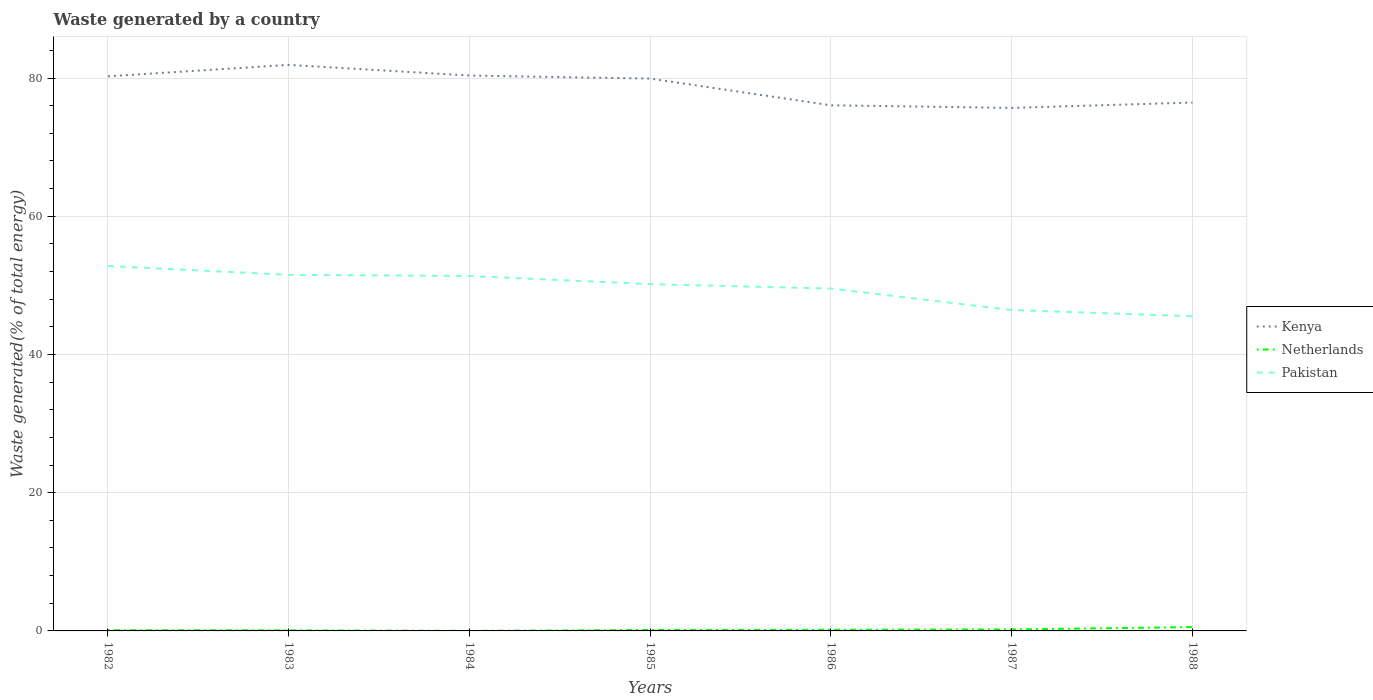Does the line corresponding to Kenya intersect with the line corresponding to Pakistan?
Ensure brevity in your answer.  No. Across all years, what is the maximum total waste generated in Netherlands?
Keep it short and to the point. 0.01. In which year was the total waste generated in Pakistan maximum?
Keep it short and to the point. 1988. What is the total total waste generated in Kenya in the graph?
Keep it short and to the point. 5.85. What is the difference between the highest and the second highest total waste generated in Kenya?
Offer a very short reply. 6.22. What is the difference between the highest and the lowest total waste generated in Kenya?
Keep it short and to the point. 4. Does the graph contain grids?
Give a very brief answer. Yes. Where does the legend appear in the graph?
Give a very brief answer. Center right. How many legend labels are there?
Your answer should be compact. 3. What is the title of the graph?
Keep it short and to the point. Waste generated by a country. What is the label or title of the X-axis?
Offer a terse response. Years. What is the label or title of the Y-axis?
Keep it short and to the point. Waste generated(% of total energy). What is the Waste generated(% of total energy) of Kenya in 1982?
Offer a very short reply. 80.25. What is the Waste generated(% of total energy) of Netherlands in 1982?
Offer a very short reply. 0.11. What is the Waste generated(% of total energy) of Pakistan in 1982?
Give a very brief answer. 52.81. What is the Waste generated(% of total energy) in Kenya in 1983?
Offer a terse response. 81.91. What is the Waste generated(% of total energy) of Netherlands in 1983?
Keep it short and to the point. 0.09. What is the Waste generated(% of total energy) in Pakistan in 1983?
Provide a short and direct response. 51.53. What is the Waste generated(% of total energy) of Kenya in 1984?
Offer a terse response. 80.36. What is the Waste generated(% of total energy) in Netherlands in 1984?
Your answer should be compact. 0.01. What is the Waste generated(% of total energy) of Pakistan in 1984?
Offer a very short reply. 51.36. What is the Waste generated(% of total energy) in Kenya in 1985?
Provide a short and direct response. 79.92. What is the Waste generated(% of total energy) of Netherlands in 1985?
Your answer should be compact. 0.14. What is the Waste generated(% of total energy) in Pakistan in 1985?
Your answer should be compact. 50.18. What is the Waste generated(% of total energy) of Kenya in 1986?
Give a very brief answer. 76.06. What is the Waste generated(% of total energy) in Netherlands in 1986?
Provide a short and direct response. 0.17. What is the Waste generated(% of total energy) of Pakistan in 1986?
Ensure brevity in your answer.  49.54. What is the Waste generated(% of total energy) in Kenya in 1987?
Make the answer very short. 75.68. What is the Waste generated(% of total energy) of Netherlands in 1987?
Ensure brevity in your answer.  0.21. What is the Waste generated(% of total energy) of Pakistan in 1987?
Your answer should be very brief. 46.44. What is the Waste generated(% of total energy) of Kenya in 1988?
Provide a succinct answer. 76.46. What is the Waste generated(% of total energy) in Netherlands in 1988?
Ensure brevity in your answer.  0.55. What is the Waste generated(% of total energy) of Pakistan in 1988?
Your answer should be compact. 45.53. Across all years, what is the maximum Waste generated(% of total energy) of Kenya?
Your answer should be compact. 81.91. Across all years, what is the maximum Waste generated(% of total energy) in Netherlands?
Your answer should be compact. 0.55. Across all years, what is the maximum Waste generated(% of total energy) in Pakistan?
Keep it short and to the point. 52.81. Across all years, what is the minimum Waste generated(% of total energy) of Kenya?
Ensure brevity in your answer.  75.68. Across all years, what is the minimum Waste generated(% of total energy) in Netherlands?
Your answer should be very brief. 0.01. Across all years, what is the minimum Waste generated(% of total energy) of Pakistan?
Offer a terse response. 45.53. What is the total Waste generated(% of total energy) in Kenya in the graph?
Provide a succinct answer. 550.64. What is the total Waste generated(% of total energy) in Netherlands in the graph?
Your answer should be compact. 1.28. What is the total Waste generated(% of total energy) of Pakistan in the graph?
Offer a terse response. 347.38. What is the difference between the Waste generated(% of total energy) in Kenya in 1982 and that in 1983?
Your answer should be compact. -1.65. What is the difference between the Waste generated(% of total energy) in Netherlands in 1982 and that in 1983?
Provide a succinct answer. 0.02. What is the difference between the Waste generated(% of total energy) of Pakistan in 1982 and that in 1983?
Make the answer very short. 1.28. What is the difference between the Waste generated(% of total energy) in Kenya in 1982 and that in 1984?
Give a very brief answer. -0.11. What is the difference between the Waste generated(% of total energy) of Netherlands in 1982 and that in 1984?
Give a very brief answer. 0.1. What is the difference between the Waste generated(% of total energy) of Pakistan in 1982 and that in 1984?
Make the answer very short. 1.45. What is the difference between the Waste generated(% of total energy) of Kenya in 1982 and that in 1985?
Your response must be concise. 0.33. What is the difference between the Waste generated(% of total energy) of Netherlands in 1982 and that in 1985?
Offer a terse response. -0.03. What is the difference between the Waste generated(% of total energy) in Pakistan in 1982 and that in 1985?
Make the answer very short. 2.62. What is the difference between the Waste generated(% of total energy) in Kenya in 1982 and that in 1986?
Give a very brief answer. 4.2. What is the difference between the Waste generated(% of total energy) of Netherlands in 1982 and that in 1986?
Keep it short and to the point. -0.06. What is the difference between the Waste generated(% of total energy) of Pakistan in 1982 and that in 1986?
Give a very brief answer. 3.27. What is the difference between the Waste generated(% of total energy) in Kenya in 1982 and that in 1987?
Your answer should be compact. 4.57. What is the difference between the Waste generated(% of total energy) of Netherlands in 1982 and that in 1987?
Provide a succinct answer. -0.1. What is the difference between the Waste generated(% of total energy) in Pakistan in 1982 and that in 1987?
Your answer should be compact. 6.37. What is the difference between the Waste generated(% of total energy) in Kenya in 1982 and that in 1988?
Offer a very short reply. 3.8. What is the difference between the Waste generated(% of total energy) in Netherlands in 1982 and that in 1988?
Provide a short and direct response. -0.45. What is the difference between the Waste generated(% of total energy) in Pakistan in 1982 and that in 1988?
Provide a short and direct response. 7.27. What is the difference between the Waste generated(% of total energy) of Kenya in 1983 and that in 1984?
Provide a short and direct response. 1.54. What is the difference between the Waste generated(% of total energy) of Netherlands in 1983 and that in 1984?
Your answer should be very brief. 0.08. What is the difference between the Waste generated(% of total energy) in Pakistan in 1983 and that in 1984?
Provide a succinct answer. 0.17. What is the difference between the Waste generated(% of total energy) of Kenya in 1983 and that in 1985?
Your answer should be very brief. 1.99. What is the difference between the Waste generated(% of total energy) in Netherlands in 1983 and that in 1985?
Give a very brief answer. -0.05. What is the difference between the Waste generated(% of total energy) in Pakistan in 1983 and that in 1985?
Ensure brevity in your answer.  1.35. What is the difference between the Waste generated(% of total energy) of Kenya in 1983 and that in 1986?
Your answer should be compact. 5.85. What is the difference between the Waste generated(% of total energy) of Netherlands in 1983 and that in 1986?
Keep it short and to the point. -0.08. What is the difference between the Waste generated(% of total energy) of Pakistan in 1983 and that in 1986?
Make the answer very short. 1.99. What is the difference between the Waste generated(% of total energy) of Kenya in 1983 and that in 1987?
Offer a terse response. 6.22. What is the difference between the Waste generated(% of total energy) of Netherlands in 1983 and that in 1987?
Your response must be concise. -0.12. What is the difference between the Waste generated(% of total energy) in Pakistan in 1983 and that in 1987?
Your response must be concise. 5.09. What is the difference between the Waste generated(% of total energy) of Kenya in 1983 and that in 1988?
Keep it short and to the point. 5.45. What is the difference between the Waste generated(% of total energy) in Netherlands in 1983 and that in 1988?
Your answer should be very brief. -0.46. What is the difference between the Waste generated(% of total energy) of Pakistan in 1983 and that in 1988?
Keep it short and to the point. 6. What is the difference between the Waste generated(% of total energy) in Kenya in 1984 and that in 1985?
Your response must be concise. 0.44. What is the difference between the Waste generated(% of total energy) of Netherlands in 1984 and that in 1985?
Offer a terse response. -0.14. What is the difference between the Waste generated(% of total energy) in Pakistan in 1984 and that in 1985?
Offer a very short reply. 1.18. What is the difference between the Waste generated(% of total energy) in Kenya in 1984 and that in 1986?
Offer a terse response. 4.31. What is the difference between the Waste generated(% of total energy) in Netherlands in 1984 and that in 1986?
Your answer should be compact. -0.16. What is the difference between the Waste generated(% of total energy) in Pakistan in 1984 and that in 1986?
Provide a short and direct response. 1.82. What is the difference between the Waste generated(% of total energy) in Kenya in 1984 and that in 1987?
Make the answer very short. 4.68. What is the difference between the Waste generated(% of total energy) of Netherlands in 1984 and that in 1987?
Keep it short and to the point. -0.21. What is the difference between the Waste generated(% of total energy) of Pakistan in 1984 and that in 1987?
Your answer should be very brief. 4.92. What is the difference between the Waste generated(% of total energy) in Kenya in 1984 and that in 1988?
Keep it short and to the point. 3.91. What is the difference between the Waste generated(% of total energy) in Netherlands in 1984 and that in 1988?
Keep it short and to the point. -0.55. What is the difference between the Waste generated(% of total energy) in Pakistan in 1984 and that in 1988?
Provide a succinct answer. 5.83. What is the difference between the Waste generated(% of total energy) in Kenya in 1985 and that in 1986?
Offer a very short reply. 3.86. What is the difference between the Waste generated(% of total energy) of Netherlands in 1985 and that in 1986?
Offer a very short reply. -0.03. What is the difference between the Waste generated(% of total energy) in Pakistan in 1985 and that in 1986?
Make the answer very short. 0.64. What is the difference between the Waste generated(% of total energy) in Kenya in 1985 and that in 1987?
Your response must be concise. 4.24. What is the difference between the Waste generated(% of total energy) in Netherlands in 1985 and that in 1987?
Provide a succinct answer. -0.07. What is the difference between the Waste generated(% of total energy) of Pakistan in 1985 and that in 1987?
Ensure brevity in your answer.  3.75. What is the difference between the Waste generated(% of total energy) of Kenya in 1985 and that in 1988?
Give a very brief answer. 3.46. What is the difference between the Waste generated(% of total energy) in Netherlands in 1985 and that in 1988?
Your answer should be compact. -0.41. What is the difference between the Waste generated(% of total energy) of Pakistan in 1985 and that in 1988?
Keep it short and to the point. 4.65. What is the difference between the Waste generated(% of total energy) of Kenya in 1986 and that in 1987?
Your answer should be very brief. 0.37. What is the difference between the Waste generated(% of total energy) of Netherlands in 1986 and that in 1987?
Your answer should be compact. -0.04. What is the difference between the Waste generated(% of total energy) in Pakistan in 1986 and that in 1987?
Make the answer very short. 3.1. What is the difference between the Waste generated(% of total energy) of Kenya in 1986 and that in 1988?
Make the answer very short. -0.4. What is the difference between the Waste generated(% of total energy) in Netherlands in 1986 and that in 1988?
Your answer should be very brief. -0.38. What is the difference between the Waste generated(% of total energy) of Pakistan in 1986 and that in 1988?
Give a very brief answer. 4.01. What is the difference between the Waste generated(% of total energy) in Kenya in 1987 and that in 1988?
Your response must be concise. -0.77. What is the difference between the Waste generated(% of total energy) of Netherlands in 1987 and that in 1988?
Provide a succinct answer. -0.34. What is the difference between the Waste generated(% of total energy) in Pakistan in 1987 and that in 1988?
Ensure brevity in your answer.  0.9. What is the difference between the Waste generated(% of total energy) in Kenya in 1982 and the Waste generated(% of total energy) in Netherlands in 1983?
Give a very brief answer. 80.16. What is the difference between the Waste generated(% of total energy) in Kenya in 1982 and the Waste generated(% of total energy) in Pakistan in 1983?
Ensure brevity in your answer.  28.73. What is the difference between the Waste generated(% of total energy) in Netherlands in 1982 and the Waste generated(% of total energy) in Pakistan in 1983?
Keep it short and to the point. -51.42. What is the difference between the Waste generated(% of total energy) of Kenya in 1982 and the Waste generated(% of total energy) of Netherlands in 1984?
Offer a terse response. 80.25. What is the difference between the Waste generated(% of total energy) of Kenya in 1982 and the Waste generated(% of total energy) of Pakistan in 1984?
Offer a terse response. 28.89. What is the difference between the Waste generated(% of total energy) of Netherlands in 1982 and the Waste generated(% of total energy) of Pakistan in 1984?
Your response must be concise. -51.25. What is the difference between the Waste generated(% of total energy) of Kenya in 1982 and the Waste generated(% of total energy) of Netherlands in 1985?
Your answer should be very brief. 80.11. What is the difference between the Waste generated(% of total energy) in Kenya in 1982 and the Waste generated(% of total energy) in Pakistan in 1985?
Make the answer very short. 30.07. What is the difference between the Waste generated(% of total energy) in Netherlands in 1982 and the Waste generated(% of total energy) in Pakistan in 1985?
Keep it short and to the point. -50.07. What is the difference between the Waste generated(% of total energy) of Kenya in 1982 and the Waste generated(% of total energy) of Netherlands in 1986?
Offer a very short reply. 80.08. What is the difference between the Waste generated(% of total energy) in Kenya in 1982 and the Waste generated(% of total energy) in Pakistan in 1986?
Ensure brevity in your answer.  30.71. What is the difference between the Waste generated(% of total energy) of Netherlands in 1982 and the Waste generated(% of total energy) of Pakistan in 1986?
Offer a terse response. -49.43. What is the difference between the Waste generated(% of total energy) of Kenya in 1982 and the Waste generated(% of total energy) of Netherlands in 1987?
Your response must be concise. 80.04. What is the difference between the Waste generated(% of total energy) of Kenya in 1982 and the Waste generated(% of total energy) of Pakistan in 1987?
Provide a succinct answer. 33.82. What is the difference between the Waste generated(% of total energy) of Netherlands in 1982 and the Waste generated(% of total energy) of Pakistan in 1987?
Your response must be concise. -46.33. What is the difference between the Waste generated(% of total energy) of Kenya in 1982 and the Waste generated(% of total energy) of Netherlands in 1988?
Provide a short and direct response. 79.7. What is the difference between the Waste generated(% of total energy) in Kenya in 1982 and the Waste generated(% of total energy) in Pakistan in 1988?
Make the answer very short. 34.72. What is the difference between the Waste generated(% of total energy) in Netherlands in 1982 and the Waste generated(% of total energy) in Pakistan in 1988?
Your response must be concise. -45.42. What is the difference between the Waste generated(% of total energy) of Kenya in 1983 and the Waste generated(% of total energy) of Netherlands in 1984?
Keep it short and to the point. 81.9. What is the difference between the Waste generated(% of total energy) of Kenya in 1983 and the Waste generated(% of total energy) of Pakistan in 1984?
Make the answer very short. 30.55. What is the difference between the Waste generated(% of total energy) in Netherlands in 1983 and the Waste generated(% of total energy) in Pakistan in 1984?
Give a very brief answer. -51.27. What is the difference between the Waste generated(% of total energy) in Kenya in 1983 and the Waste generated(% of total energy) in Netherlands in 1985?
Ensure brevity in your answer.  81.77. What is the difference between the Waste generated(% of total energy) of Kenya in 1983 and the Waste generated(% of total energy) of Pakistan in 1985?
Provide a short and direct response. 31.72. What is the difference between the Waste generated(% of total energy) of Netherlands in 1983 and the Waste generated(% of total energy) of Pakistan in 1985?
Provide a succinct answer. -50.09. What is the difference between the Waste generated(% of total energy) of Kenya in 1983 and the Waste generated(% of total energy) of Netherlands in 1986?
Your answer should be very brief. 81.74. What is the difference between the Waste generated(% of total energy) in Kenya in 1983 and the Waste generated(% of total energy) in Pakistan in 1986?
Offer a very short reply. 32.37. What is the difference between the Waste generated(% of total energy) of Netherlands in 1983 and the Waste generated(% of total energy) of Pakistan in 1986?
Your response must be concise. -49.45. What is the difference between the Waste generated(% of total energy) of Kenya in 1983 and the Waste generated(% of total energy) of Netherlands in 1987?
Your answer should be very brief. 81.69. What is the difference between the Waste generated(% of total energy) in Kenya in 1983 and the Waste generated(% of total energy) in Pakistan in 1987?
Keep it short and to the point. 35.47. What is the difference between the Waste generated(% of total energy) in Netherlands in 1983 and the Waste generated(% of total energy) in Pakistan in 1987?
Keep it short and to the point. -46.35. What is the difference between the Waste generated(% of total energy) of Kenya in 1983 and the Waste generated(% of total energy) of Netherlands in 1988?
Your answer should be compact. 81.35. What is the difference between the Waste generated(% of total energy) of Kenya in 1983 and the Waste generated(% of total energy) of Pakistan in 1988?
Your response must be concise. 36.37. What is the difference between the Waste generated(% of total energy) in Netherlands in 1983 and the Waste generated(% of total energy) in Pakistan in 1988?
Ensure brevity in your answer.  -45.44. What is the difference between the Waste generated(% of total energy) of Kenya in 1984 and the Waste generated(% of total energy) of Netherlands in 1985?
Your answer should be very brief. 80.22. What is the difference between the Waste generated(% of total energy) of Kenya in 1984 and the Waste generated(% of total energy) of Pakistan in 1985?
Offer a terse response. 30.18. What is the difference between the Waste generated(% of total energy) of Netherlands in 1984 and the Waste generated(% of total energy) of Pakistan in 1985?
Your answer should be compact. -50.18. What is the difference between the Waste generated(% of total energy) of Kenya in 1984 and the Waste generated(% of total energy) of Netherlands in 1986?
Offer a very short reply. 80.19. What is the difference between the Waste generated(% of total energy) of Kenya in 1984 and the Waste generated(% of total energy) of Pakistan in 1986?
Keep it short and to the point. 30.82. What is the difference between the Waste generated(% of total energy) in Netherlands in 1984 and the Waste generated(% of total energy) in Pakistan in 1986?
Offer a terse response. -49.53. What is the difference between the Waste generated(% of total energy) in Kenya in 1984 and the Waste generated(% of total energy) in Netherlands in 1987?
Keep it short and to the point. 80.15. What is the difference between the Waste generated(% of total energy) in Kenya in 1984 and the Waste generated(% of total energy) in Pakistan in 1987?
Provide a succinct answer. 33.93. What is the difference between the Waste generated(% of total energy) in Netherlands in 1984 and the Waste generated(% of total energy) in Pakistan in 1987?
Offer a terse response. -46.43. What is the difference between the Waste generated(% of total energy) of Kenya in 1984 and the Waste generated(% of total energy) of Netherlands in 1988?
Provide a succinct answer. 79.81. What is the difference between the Waste generated(% of total energy) of Kenya in 1984 and the Waste generated(% of total energy) of Pakistan in 1988?
Offer a terse response. 34.83. What is the difference between the Waste generated(% of total energy) in Netherlands in 1984 and the Waste generated(% of total energy) in Pakistan in 1988?
Give a very brief answer. -45.53. What is the difference between the Waste generated(% of total energy) in Kenya in 1985 and the Waste generated(% of total energy) in Netherlands in 1986?
Provide a succinct answer. 79.75. What is the difference between the Waste generated(% of total energy) of Kenya in 1985 and the Waste generated(% of total energy) of Pakistan in 1986?
Provide a short and direct response. 30.38. What is the difference between the Waste generated(% of total energy) of Netherlands in 1985 and the Waste generated(% of total energy) of Pakistan in 1986?
Your response must be concise. -49.4. What is the difference between the Waste generated(% of total energy) in Kenya in 1985 and the Waste generated(% of total energy) in Netherlands in 1987?
Ensure brevity in your answer.  79.71. What is the difference between the Waste generated(% of total energy) of Kenya in 1985 and the Waste generated(% of total energy) of Pakistan in 1987?
Provide a short and direct response. 33.48. What is the difference between the Waste generated(% of total energy) of Netherlands in 1985 and the Waste generated(% of total energy) of Pakistan in 1987?
Ensure brevity in your answer.  -46.29. What is the difference between the Waste generated(% of total energy) in Kenya in 1985 and the Waste generated(% of total energy) in Netherlands in 1988?
Your answer should be very brief. 79.36. What is the difference between the Waste generated(% of total energy) of Kenya in 1985 and the Waste generated(% of total energy) of Pakistan in 1988?
Your answer should be compact. 34.39. What is the difference between the Waste generated(% of total energy) in Netherlands in 1985 and the Waste generated(% of total energy) in Pakistan in 1988?
Ensure brevity in your answer.  -45.39. What is the difference between the Waste generated(% of total energy) in Kenya in 1986 and the Waste generated(% of total energy) in Netherlands in 1987?
Your response must be concise. 75.84. What is the difference between the Waste generated(% of total energy) in Kenya in 1986 and the Waste generated(% of total energy) in Pakistan in 1987?
Make the answer very short. 29.62. What is the difference between the Waste generated(% of total energy) of Netherlands in 1986 and the Waste generated(% of total energy) of Pakistan in 1987?
Provide a short and direct response. -46.27. What is the difference between the Waste generated(% of total energy) of Kenya in 1986 and the Waste generated(% of total energy) of Netherlands in 1988?
Make the answer very short. 75.5. What is the difference between the Waste generated(% of total energy) of Kenya in 1986 and the Waste generated(% of total energy) of Pakistan in 1988?
Make the answer very short. 30.52. What is the difference between the Waste generated(% of total energy) of Netherlands in 1986 and the Waste generated(% of total energy) of Pakistan in 1988?
Your answer should be compact. -45.36. What is the difference between the Waste generated(% of total energy) of Kenya in 1987 and the Waste generated(% of total energy) of Netherlands in 1988?
Provide a succinct answer. 75.13. What is the difference between the Waste generated(% of total energy) in Kenya in 1987 and the Waste generated(% of total energy) in Pakistan in 1988?
Offer a very short reply. 30.15. What is the difference between the Waste generated(% of total energy) in Netherlands in 1987 and the Waste generated(% of total energy) in Pakistan in 1988?
Your answer should be very brief. -45.32. What is the average Waste generated(% of total energy) in Kenya per year?
Make the answer very short. 78.66. What is the average Waste generated(% of total energy) in Netherlands per year?
Provide a succinct answer. 0.18. What is the average Waste generated(% of total energy) in Pakistan per year?
Your answer should be compact. 49.63. In the year 1982, what is the difference between the Waste generated(% of total energy) in Kenya and Waste generated(% of total energy) in Netherlands?
Your answer should be very brief. 80.15. In the year 1982, what is the difference between the Waste generated(% of total energy) of Kenya and Waste generated(% of total energy) of Pakistan?
Your response must be concise. 27.45. In the year 1982, what is the difference between the Waste generated(% of total energy) of Netherlands and Waste generated(% of total energy) of Pakistan?
Provide a succinct answer. -52.7. In the year 1983, what is the difference between the Waste generated(% of total energy) of Kenya and Waste generated(% of total energy) of Netherlands?
Ensure brevity in your answer.  81.82. In the year 1983, what is the difference between the Waste generated(% of total energy) of Kenya and Waste generated(% of total energy) of Pakistan?
Offer a terse response. 30.38. In the year 1983, what is the difference between the Waste generated(% of total energy) in Netherlands and Waste generated(% of total energy) in Pakistan?
Make the answer very short. -51.44. In the year 1984, what is the difference between the Waste generated(% of total energy) in Kenya and Waste generated(% of total energy) in Netherlands?
Give a very brief answer. 80.36. In the year 1984, what is the difference between the Waste generated(% of total energy) in Kenya and Waste generated(% of total energy) in Pakistan?
Keep it short and to the point. 29. In the year 1984, what is the difference between the Waste generated(% of total energy) of Netherlands and Waste generated(% of total energy) of Pakistan?
Offer a very short reply. -51.35. In the year 1985, what is the difference between the Waste generated(% of total energy) in Kenya and Waste generated(% of total energy) in Netherlands?
Your response must be concise. 79.78. In the year 1985, what is the difference between the Waste generated(% of total energy) in Kenya and Waste generated(% of total energy) in Pakistan?
Offer a terse response. 29.74. In the year 1985, what is the difference between the Waste generated(% of total energy) of Netherlands and Waste generated(% of total energy) of Pakistan?
Keep it short and to the point. -50.04. In the year 1986, what is the difference between the Waste generated(% of total energy) in Kenya and Waste generated(% of total energy) in Netherlands?
Your answer should be very brief. 75.89. In the year 1986, what is the difference between the Waste generated(% of total energy) in Kenya and Waste generated(% of total energy) in Pakistan?
Your answer should be compact. 26.52. In the year 1986, what is the difference between the Waste generated(% of total energy) in Netherlands and Waste generated(% of total energy) in Pakistan?
Offer a very short reply. -49.37. In the year 1987, what is the difference between the Waste generated(% of total energy) in Kenya and Waste generated(% of total energy) in Netherlands?
Provide a succinct answer. 75.47. In the year 1987, what is the difference between the Waste generated(% of total energy) of Kenya and Waste generated(% of total energy) of Pakistan?
Provide a short and direct response. 29.25. In the year 1987, what is the difference between the Waste generated(% of total energy) in Netherlands and Waste generated(% of total energy) in Pakistan?
Offer a terse response. -46.22. In the year 1988, what is the difference between the Waste generated(% of total energy) of Kenya and Waste generated(% of total energy) of Netherlands?
Offer a terse response. 75.9. In the year 1988, what is the difference between the Waste generated(% of total energy) in Kenya and Waste generated(% of total energy) in Pakistan?
Your answer should be compact. 30.92. In the year 1988, what is the difference between the Waste generated(% of total energy) of Netherlands and Waste generated(% of total energy) of Pakistan?
Make the answer very short. -44.98. What is the ratio of the Waste generated(% of total energy) in Kenya in 1982 to that in 1983?
Keep it short and to the point. 0.98. What is the ratio of the Waste generated(% of total energy) in Netherlands in 1982 to that in 1983?
Your answer should be compact. 1.2. What is the ratio of the Waste generated(% of total energy) of Pakistan in 1982 to that in 1983?
Keep it short and to the point. 1.02. What is the ratio of the Waste generated(% of total energy) in Netherlands in 1982 to that in 1984?
Provide a short and direct response. 17.39. What is the ratio of the Waste generated(% of total energy) of Pakistan in 1982 to that in 1984?
Your answer should be compact. 1.03. What is the ratio of the Waste generated(% of total energy) of Kenya in 1982 to that in 1985?
Offer a very short reply. 1. What is the ratio of the Waste generated(% of total energy) in Netherlands in 1982 to that in 1985?
Provide a short and direct response. 0.76. What is the ratio of the Waste generated(% of total energy) in Pakistan in 1982 to that in 1985?
Make the answer very short. 1.05. What is the ratio of the Waste generated(% of total energy) in Kenya in 1982 to that in 1986?
Make the answer very short. 1.06. What is the ratio of the Waste generated(% of total energy) in Netherlands in 1982 to that in 1986?
Offer a very short reply. 0.63. What is the ratio of the Waste generated(% of total energy) in Pakistan in 1982 to that in 1986?
Your response must be concise. 1.07. What is the ratio of the Waste generated(% of total energy) in Kenya in 1982 to that in 1987?
Your response must be concise. 1.06. What is the ratio of the Waste generated(% of total energy) of Netherlands in 1982 to that in 1987?
Make the answer very short. 0.51. What is the ratio of the Waste generated(% of total energy) in Pakistan in 1982 to that in 1987?
Your answer should be compact. 1.14. What is the ratio of the Waste generated(% of total energy) in Kenya in 1982 to that in 1988?
Offer a very short reply. 1.05. What is the ratio of the Waste generated(% of total energy) in Netherlands in 1982 to that in 1988?
Your answer should be very brief. 0.19. What is the ratio of the Waste generated(% of total energy) of Pakistan in 1982 to that in 1988?
Your response must be concise. 1.16. What is the ratio of the Waste generated(% of total energy) in Kenya in 1983 to that in 1984?
Provide a short and direct response. 1.02. What is the ratio of the Waste generated(% of total energy) of Netherlands in 1983 to that in 1984?
Keep it short and to the point. 14.55. What is the ratio of the Waste generated(% of total energy) of Pakistan in 1983 to that in 1984?
Keep it short and to the point. 1. What is the ratio of the Waste generated(% of total energy) in Kenya in 1983 to that in 1985?
Give a very brief answer. 1.02. What is the ratio of the Waste generated(% of total energy) of Netherlands in 1983 to that in 1985?
Your response must be concise. 0.64. What is the ratio of the Waste generated(% of total energy) of Pakistan in 1983 to that in 1985?
Your response must be concise. 1.03. What is the ratio of the Waste generated(% of total energy) in Netherlands in 1983 to that in 1986?
Provide a short and direct response. 0.53. What is the ratio of the Waste generated(% of total energy) in Pakistan in 1983 to that in 1986?
Make the answer very short. 1.04. What is the ratio of the Waste generated(% of total energy) in Kenya in 1983 to that in 1987?
Your response must be concise. 1.08. What is the ratio of the Waste generated(% of total energy) of Netherlands in 1983 to that in 1987?
Your response must be concise. 0.42. What is the ratio of the Waste generated(% of total energy) of Pakistan in 1983 to that in 1987?
Your response must be concise. 1.11. What is the ratio of the Waste generated(% of total energy) in Kenya in 1983 to that in 1988?
Your answer should be compact. 1.07. What is the ratio of the Waste generated(% of total energy) in Netherlands in 1983 to that in 1988?
Ensure brevity in your answer.  0.16. What is the ratio of the Waste generated(% of total energy) in Pakistan in 1983 to that in 1988?
Give a very brief answer. 1.13. What is the ratio of the Waste generated(% of total energy) of Kenya in 1984 to that in 1985?
Offer a terse response. 1.01. What is the ratio of the Waste generated(% of total energy) in Netherlands in 1984 to that in 1985?
Ensure brevity in your answer.  0.04. What is the ratio of the Waste generated(% of total energy) in Pakistan in 1984 to that in 1985?
Offer a very short reply. 1.02. What is the ratio of the Waste generated(% of total energy) of Kenya in 1984 to that in 1986?
Your response must be concise. 1.06. What is the ratio of the Waste generated(% of total energy) of Netherlands in 1984 to that in 1986?
Your answer should be very brief. 0.04. What is the ratio of the Waste generated(% of total energy) of Pakistan in 1984 to that in 1986?
Provide a succinct answer. 1.04. What is the ratio of the Waste generated(% of total energy) of Kenya in 1984 to that in 1987?
Offer a very short reply. 1.06. What is the ratio of the Waste generated(% of total energy) in Netherlands in 1984 to that in 1987?
Provide a succinct answer. 0.03. What is the ratio of the Waste generated(% of total energy) in Pakistan in 1984 to that in 1987?
Offer a very short reply. 1.11. What is the ratio of the Waste generated(% of total energy) of Kenya in 1984 to that in 1988?
Make the answer very short. 1.05. What is the ratio of the Waste generated(% of total energy) of Netherlands in 1984 to that in 1988?
Your response must be concise. 0.01. What is the ratio of the Waste generated(% of total energy) of Pakistan in 1984 to that in 1988?
Your answer should be very brief. 1.13. What is the ratio of the Waste generated(% of total energy) in Kenya in 1985 to that in 1986?
Ensure brevity in your answer.  1.05. What is the ratio of the Waste generated(% of total energy) in Netherlands in 1985 to that in 1986?
Keep it short and to the point. 0.83. What is the ratio of the Waste generated(% of total energy) in Kenya in 1985 to that in 1987?
Provide a succinct answer. 1.06. What is the ratio of the Waste generated(% of total energy) in Netherlands in 1985 to that in 1987?
Keep it short and to the point. 0.67. What is the ratio of the Waste generated(% of total energy) in Pakistan in 1985 to that in 1987?
Your response must be concise. 1.08. What is the ratio of the Waste generated(% of total energy) in Kenya in 1985 to that in 1988?
Keep it short and to the point. 1.05. What is the ratio of the Waste generated(% of total energy) in Netherlands in 1985 to that in 1988?
Keep it short and to the point. 0.25. What is the ratio of the Waste generated(% of total energy) in Pakistan in 1985 to that in 1988?
Your answer should be very brief. 1.1. What is the ratio of the Waste generated(% of total energy) in Kenya in 1986 to that in 1987?
Offer a terse response. 1. What is the ratio of the Waste generated(% of total energy) of Netherlands in 1986 to that in 1987?
Your answer should be compact. 0.81. What is the ratio of the Waste generated(% of total energy) in Pakistan in 1986 to that in 1987?
Your answer should be compact. 1.07. What is the ratio of the Waste generated(% of total energy) of Kenya in 1986 to that in 1988?
Your answer should be very brief. 0.99. What is the ratio of the Waste generated(% of total energy) of Netherlands in 1986 to that in 1988?
Your answer should be very brief. 0.31. What is the ratio of the Waste generated(% of total energy) of Pakistan in 1986 to that in 1988?
Give a very brief answer. 1.09. What is the ratio of the Waste generated(% of total energy) of Kenya in 1987 to that in 1988?
Offer a very short reply. 0.99. What is the ratio of the Waste generated(% of total energy) in Netherlands in 1987 to that in 1988?
Keep it short and to the point. 0.38. What is the ratio of the Waste generated(% of total energy) in Pakistan in 1987 to that in 1988?
Ensure brevity in your answer.  1.02. What is the difference between the highest and the second highest Waste generated(% of total energy) of Kenya?
Keep it short and to the point. 1.54. What is the difference between the highest and the second highest Waste generated(% of total energy) in Netherlands?
Offer a very short reply. 0.34. What is the difference between the highest and the second highest Waste generated(% of total energy) of Pakistan?
Your answer should be very brief. 1.28. What is the difference between the highest and the lowest Waste generated(% of total energy) of Kenya?
Your answer should be compact. 6.22. What is the difference between the highest and the lowest Waste generated(% of total energy) of Netherlands?
Provide a succinct answer. 0.55. What is the difference between the highest and the lowest Waste generated(% of total energy) in Pakistan?
Offer a terse response. 7.27. 